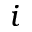<formula> <loc_0><loc_0><loc_500><loc_500>i</formula> 